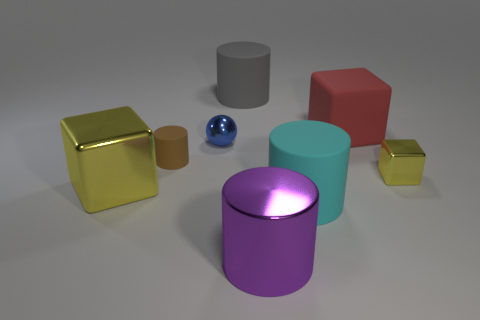Subtract all cyan matte cylinders. How many cylinders are left? 3 Add 1 green rubber balls. How many objects exist? 9 Subtract all red blocks. How many blocks are left? 2 Subtract all yellow cylinders. Subtract all red blocks. How many cylinders are left? 4 Subtract all blue cylinders. How many yellow blocks are left? 2 Subtract all brown matte cylinders. Subtract all purple metal things. How many objects are left? 6 Add 5 red rubber objects. How many red rubber objects are left? 6 Add 6 blue cylinders. How many blue cylinders exist? 6 Subtract 0 red balls. How many objects are left? 8 Subtract all balls. How many objects are left? 7 